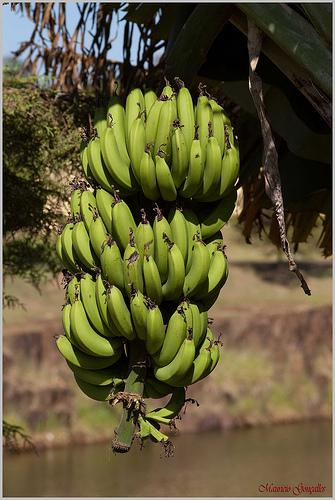Question: what fruit is this?
Choices:
A. Bananas.
B. Oranges.
C. Strawberries.
D. Tomatoes.
Answer with the letter. Answer: A Question: what color are the bananas?
Choices:
A. Green-yellow.
B. Yellow.
C. Brown.
D. Black.
Answer with the letter. Answer: A Question: who is eating bananas?
Choices:
A. Everyone.
B. No one.
C. The children.
D. The monkies.
Answer with the letter. Answer: B Question: where are the bananas?
Choices:
A. On the table.
B. In the basket.
C. At the super market.
D. Hanging from a tree.
Answer with the letter. Answer: D Question: what color is the water?
Choices:
A. Blue.
B. Green.
C. Brown.
D. Clear.
Answer with the letter. Answer: C 